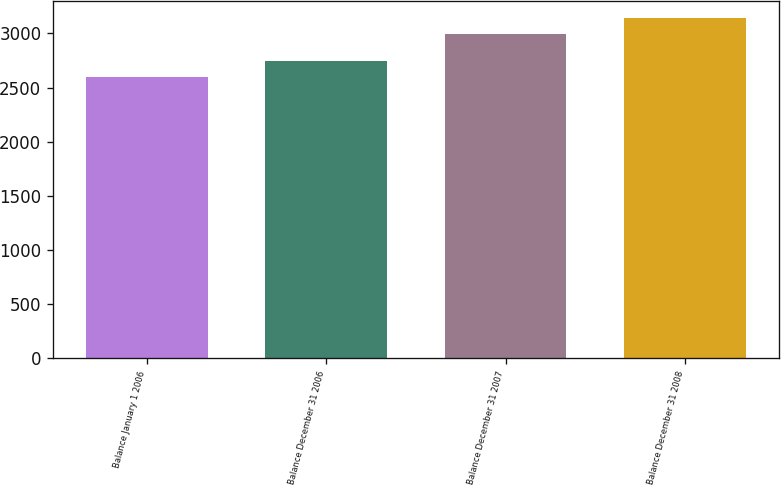<chart> <loc_0><loc_0><loc_500><loc_500><bar_chart><fcel>Balance January 1 2006<fcel>Balance December 31 2006<fcel>Balance December 31 2007<fcel>Balance December 31 2008<nl><fcel>2601.1<fcel>2743.2<fcel>2999.1<fcel>3138.5<nl></chart> 